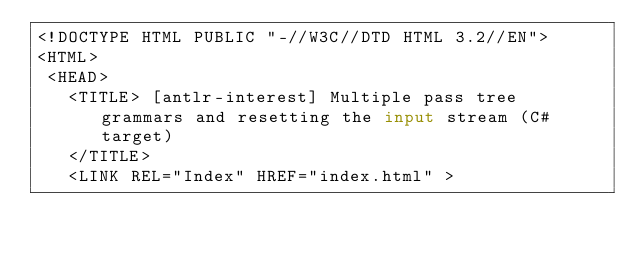<code> <loc_0><loc_0><loc_500><loc_500><_HTML_><!DOCTYPE HTML PUBLIC "-//W3C//DTD HTML 3.2//EN">
<HTML>
 <HEAD>
   <TITLE> [antlr-interest] Multiple pass tree grammars and resetting the input stream (C# target)
   </TITLE>
   <LINK REL="Index" HREF="index.html" ></code> 